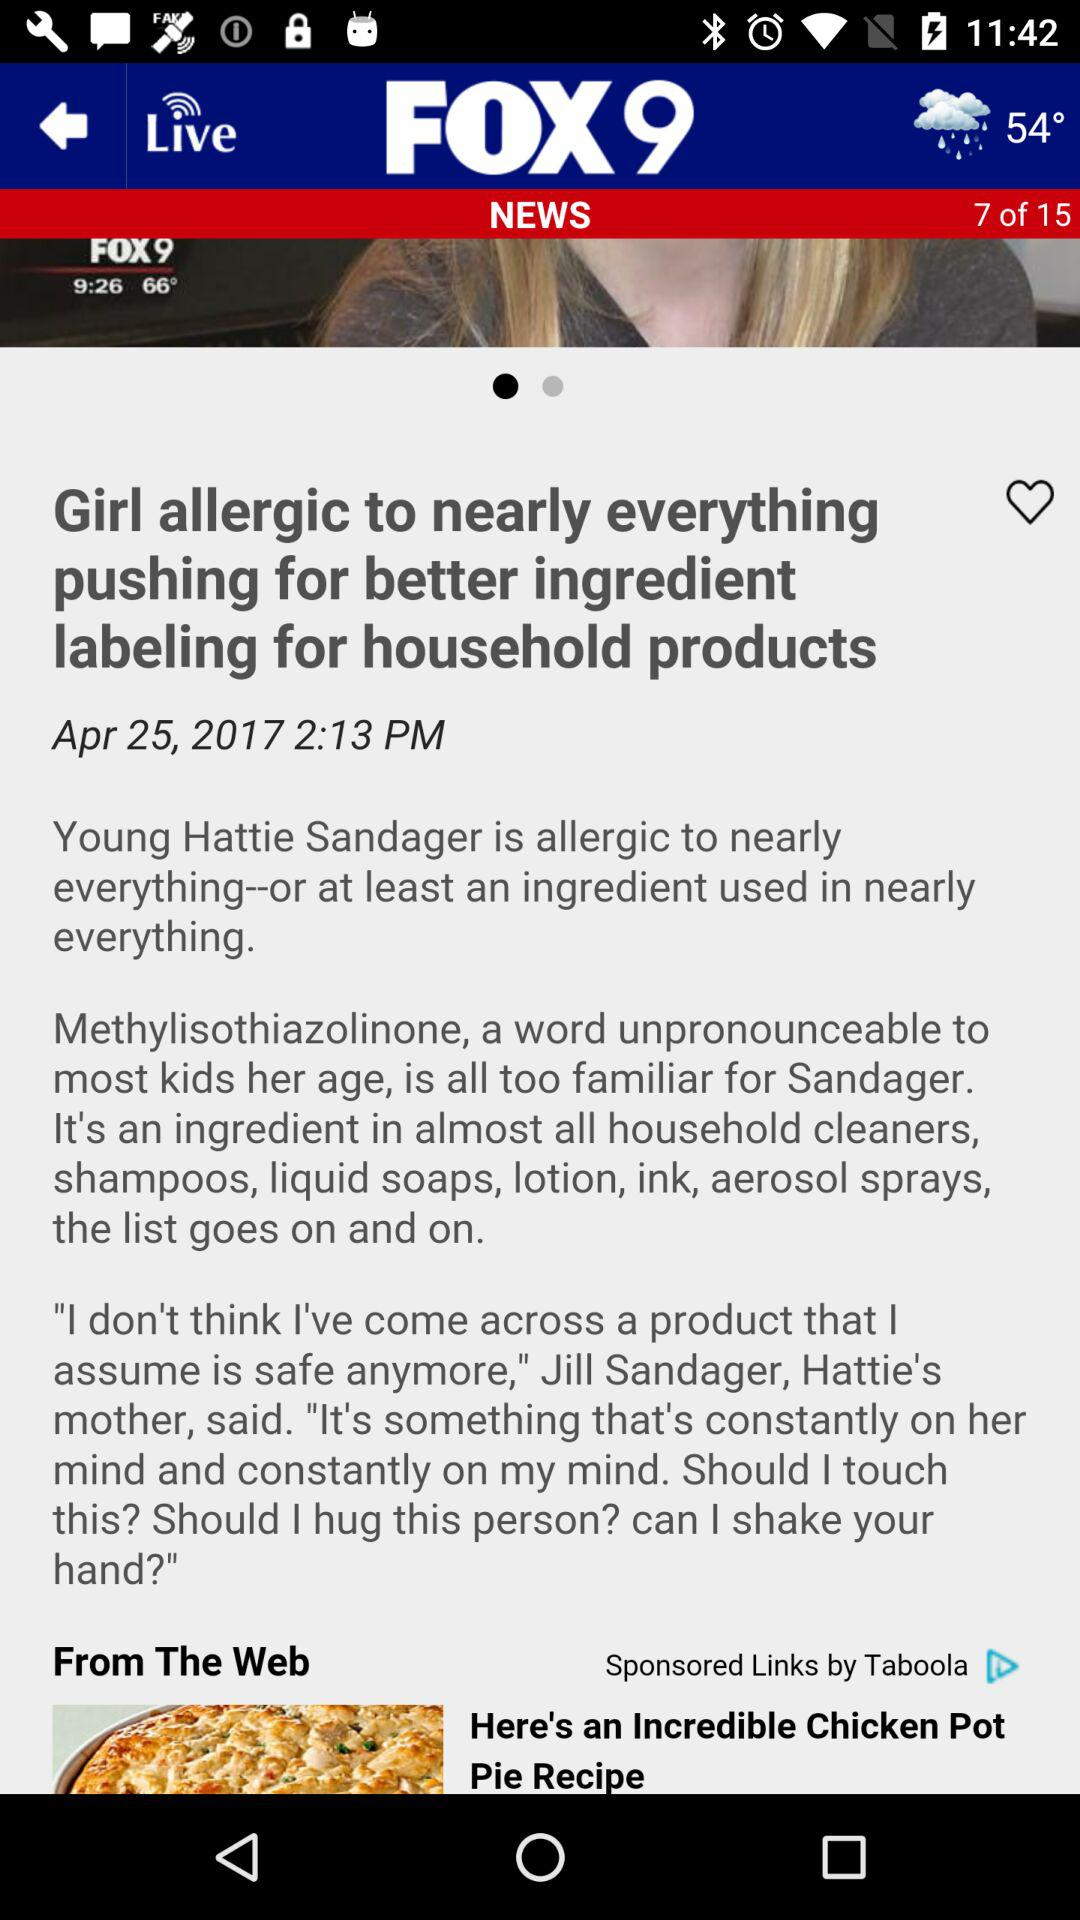What is the displayed temperature in the application at 9:26? At 9:26, the temperature displayed in the application is 66°. 